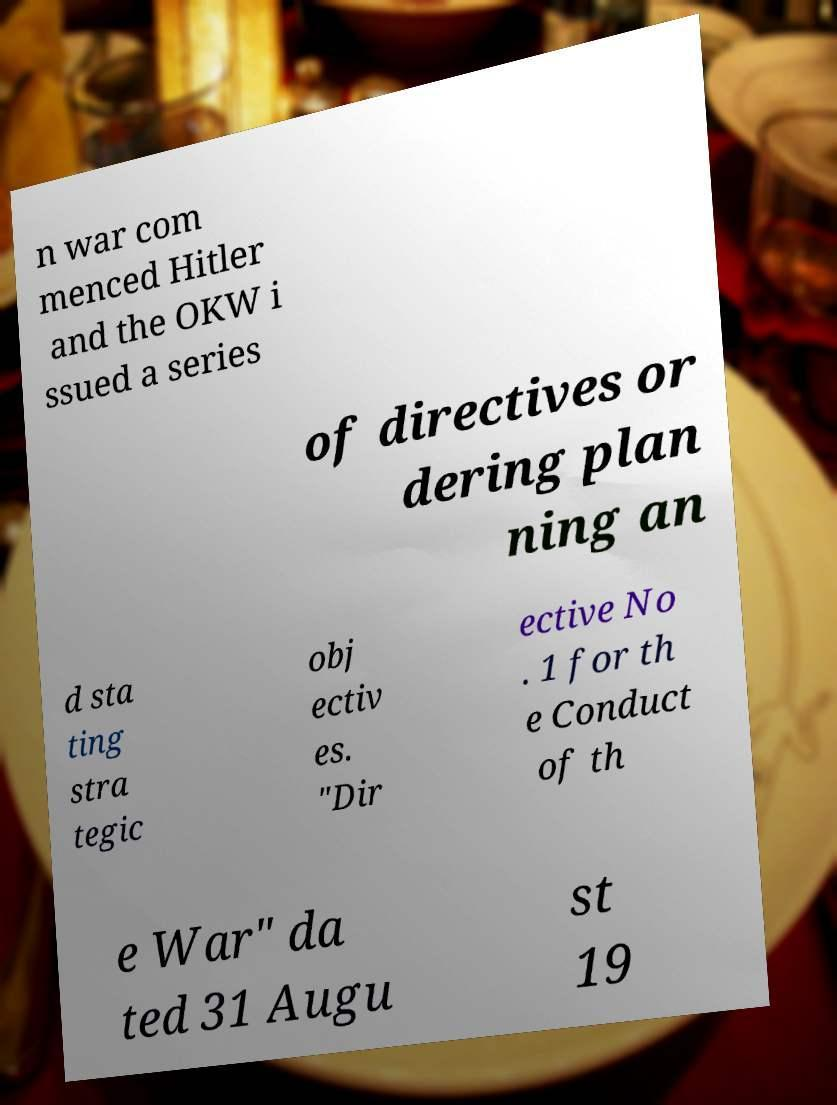There's text embedded in this image that I need extracted. Can you transcribe it verbatim? n war com menced Hitler and the OKW i ssued a series of directives or dering plan ning an d sta ting stra tegic obj ectiv es. "Dir ective No . 1 for th e Conduct of th e War" da ted 31 Augu st 19 